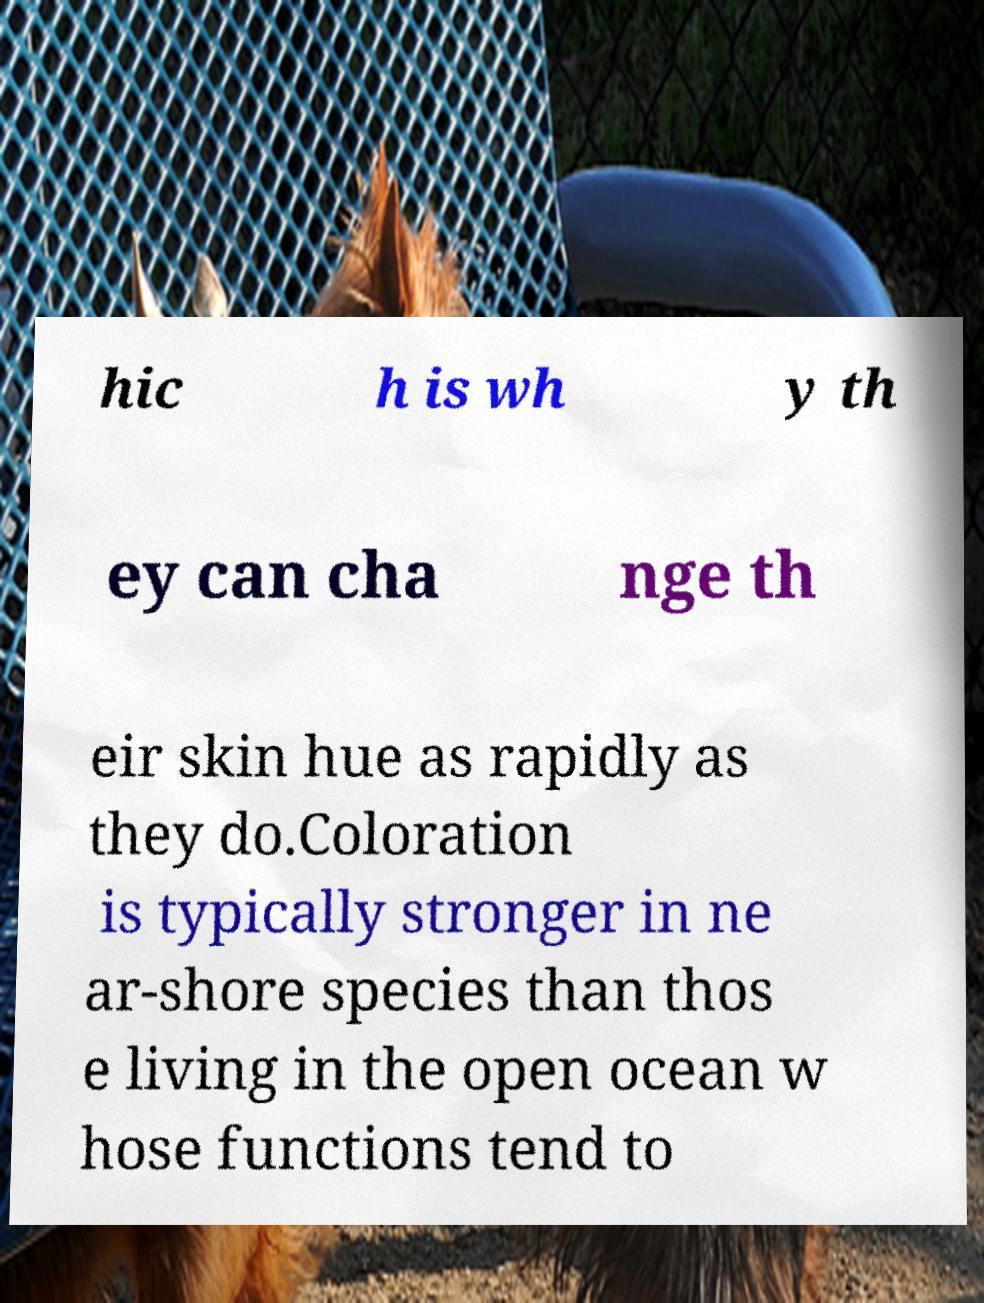I need the written content from this picture converted into text. Can you do that? hic h is wh y th ey can cha nge th eir skin hue as rapidly as they do.Coloration is typically stronger in ne ar-shore species than thos e living in the open ocean w hose functions tend to 